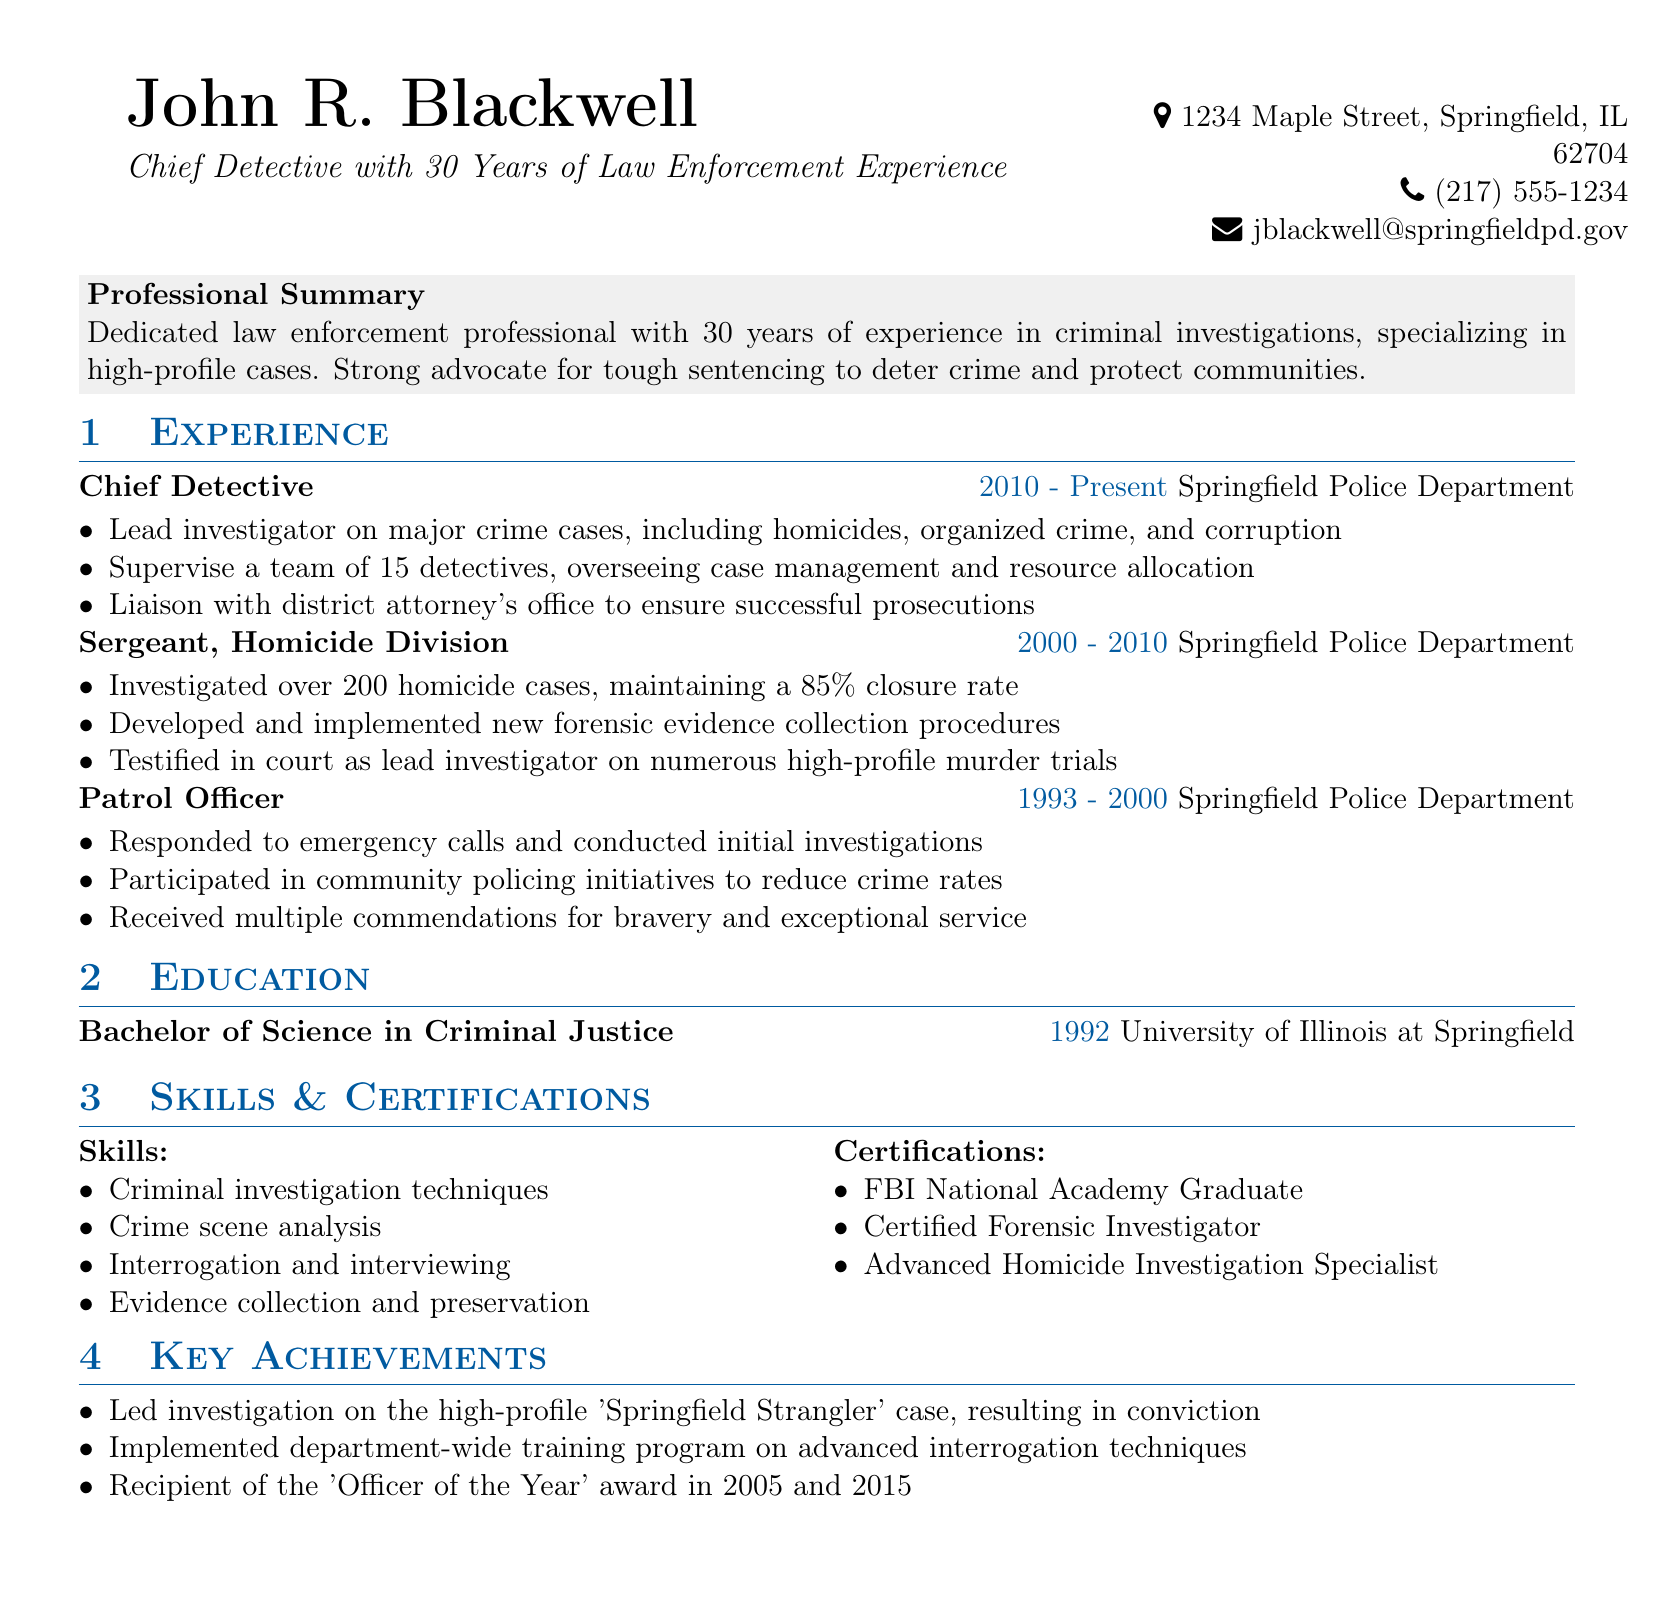What is the name of the individual? The document highlights the personal information of John R. Blackwell, which includes his name.
Answer: John R. Blackwell What is John R. Blackwell's current job title? The document states that John R. Blackwell is currently a Chief Detective.
Answer: Chief Detective How many years of experience does John R. Blackwell have? According to the summary, he has 30 years of experience in law enforcement.
Answer: 30 years What percentage closure rate did John R. Blackwell maintain in homicide cases? It is mentioned that he maintained an 85% closure rate in over 200 homicide cases.
Answer: 85% Which award did John R. Blackwell receive in 2005? The document states he was the recipient of the 'Officer of the Year' award in 2005.
Answer: Officer of the Year What significant case did John R. Blackwell lead the investigation on? The document mentions he led the investigation on the high-profile 'Springfield Strangler' case.
Answer: Springfield Strangler What degree does John R. Blackwell hold? The education section specifies that his degree is a Bachelor of Science in Criminal Justice.
Answer: Bachelor of Science in Criminal Justice How many detectives does John R. Blackwell supervise? It specifies that he supervises a team of 15 detectives.
Answer: 15 What organization did John R. Blackwell work for? The document indicates he worked for the Springfield Police Department throughout his career.
Answer: Springfield Police Department 